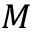<formula> <loc_0><loc_0><loc_500><loc_500>M</formula> 